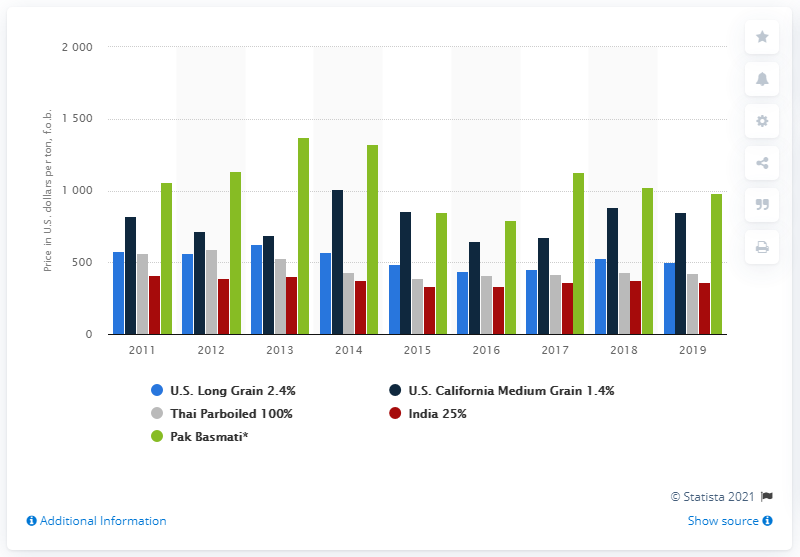Mention a couple of crucial points in this snapshot. In 2019, the average export price of one metric ton of California Medium Grain rice was approximately $850. 